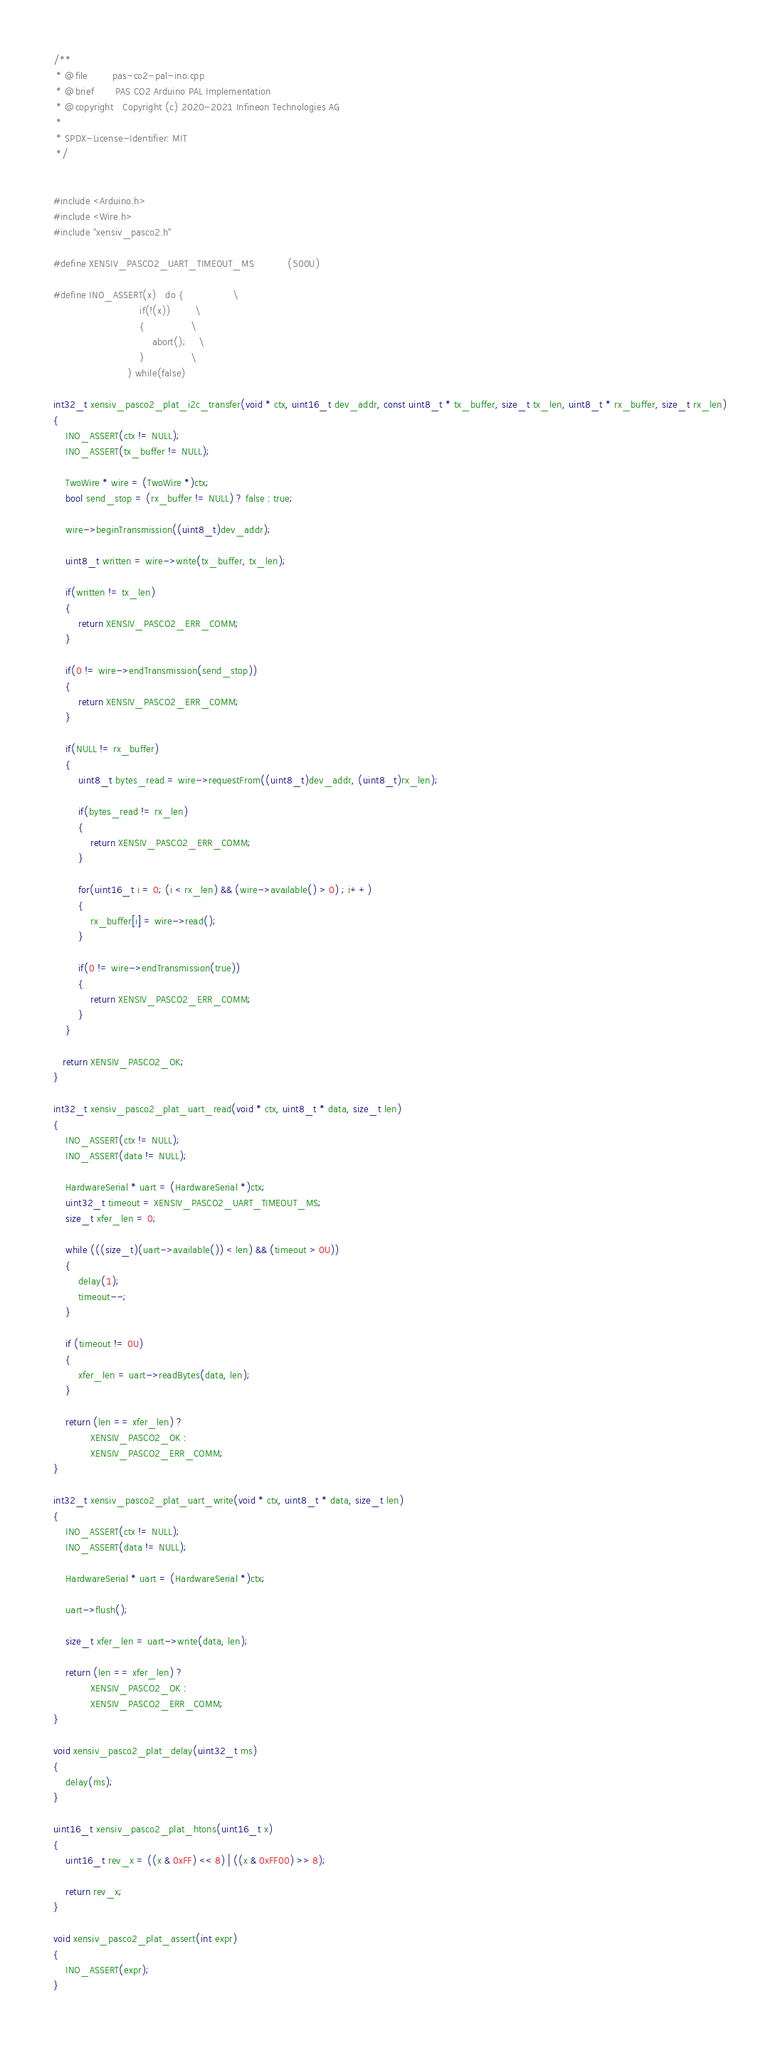<code> <loc_0><loc_0><loc_500><loc_500><_C++_>/** 
 * @file        pas-co2-pal-ino.cpp
 * @brief       PAS CO2 Arduino PAL Implementation
 * @copyright   Copyright (c) 2020-2021 Infineon Technologies AG
 *              
 * SPDX-License-Identifier: MIT
 */


#include <Arduino.h>
#include <Wire.h>
#include "xensiv_pasco2.h"

#define XENSIV_PASCO2_UART_TIMEOUT_MS           (500U)

#define INO_ASSERT(x)   do {                \
                            if(!(x))        \
                            {               \
                                abort();    \
                            }               \
                        } while(false)

int32_t xensiv_pasco2_plat_i2c_transfer(void * ctx, uint16_t dev_addr, const uint8_t * tx_buffer, size_t tx_len, uint8_t * rx_buffer, size_t rx_len)
{
    INO_ASSERT(ctx != NULL);
    INO_ASSERT(tx_buffer != NULL);    

    TwoWire * wire = (TwoWire *)ctx;
    bool send_stop = (rx_buffer != NULL) ? false : true;
    
    wire->beginTransmission((uint8_t)dev_addr);

    uint8_t written = wire->write(tx_buffer, tx_len);

    if(written != tx_len)
    {
        return XENSIV_PASCO2_ERR_COMM;
    }

    if(0 != wire->endTransmission(send_stop))
    {
        return XENSIV_PASCO2_ERR_COMM;
    }

    if(NULL != rx_buffer)
    {
        uint8_t bytes_read = wire->requestFrom((uint8_t)dev_addr, (uint8_t)rx_len);

        if(bytes_read != rx_len)
        {
            return XENSIV_PASCO2_ERR_COMM;
        }

        for(uint16_t i = 0; (i < rx_len) && (wire->available() > 0) ; i++)
        {
            rx_buffer[i] = wire->read();
        }

        if(0 != wire->endTransmission(true))
        {
            return XENSIV_PASCO2_ERR_COMM;
        } 
    }

   return XENSIV_PASCO2_OK;
}

int32_t xensiv_pasco2_plat_uart_read(void * ctx, uint8_t * data, size_t len)
{
    INO_ASSERT(ctx != NULL);
    INO_ASSERT(data != NULL);

    HardwareSerial * uart = (HardwareSerial *)ctx;
    uint32_t timeout = XENSIV_PASCO2_UART_TIMEOUT_MS;
    size_t xfer_len = 0;

    while (((size_t)(uart->available()) < len) && (timeout > 0U))
    {
        delay(1);
        timeout--;
    }

    if (timeout != 0U)
    {
        xfer_len = uart->readBytes(data, len);
    }

    return (len == xfer_len) ? 
            XENSIV_PASCO2_OK : 
            XENSIV_PASCO2_ERR_COMM;
}

int32_t xensiv_pasco2_plat_uart_write(void * ctx, uint8_t * data, size_t len)
{
    INO_ASSERT(ctx != NULL);
    INO_ASSERT(data != NULL);
        
    HardwareSerial * uart = (HardwareSerial *)ctx;

    uart->flush();

    size_t xfer_len = uart->write(data, len);

    return (len == xfer_len) ? 
            XENSIV_PASCO2_OK : 
            XENSIV_PASCO2_ERR_COMM;
}

void xensiv_pasco2_plat_delay(uint32_t ms)
{
    delay(ms);
}

uint16_t xensiv_pasco2_plat_htons(uint16_t x)
{
    uint16_t rev_x = ((x & 0xFF) << 8) | ((x & 0xFF00) >> 8);

    return rev_x;
}

void xensiv_pasco2_plat_assert(int expr)
{
    INO_ASSERT(expr);
}</code> 